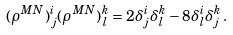<formula> <loc_0><loc_0><loc_500><loc_500>( \rho ^ { M N } ) ^ { i } _ { \, j } ( \rho ^ { M N } ) ^ { k } _ { \, l } = 2 \delta ^ { i } _ { j } \delta ^ { k } _ { l } - 8 \delta ^ { i } _ { l } \delta ^ { k } _ { j } \, .</formula> 